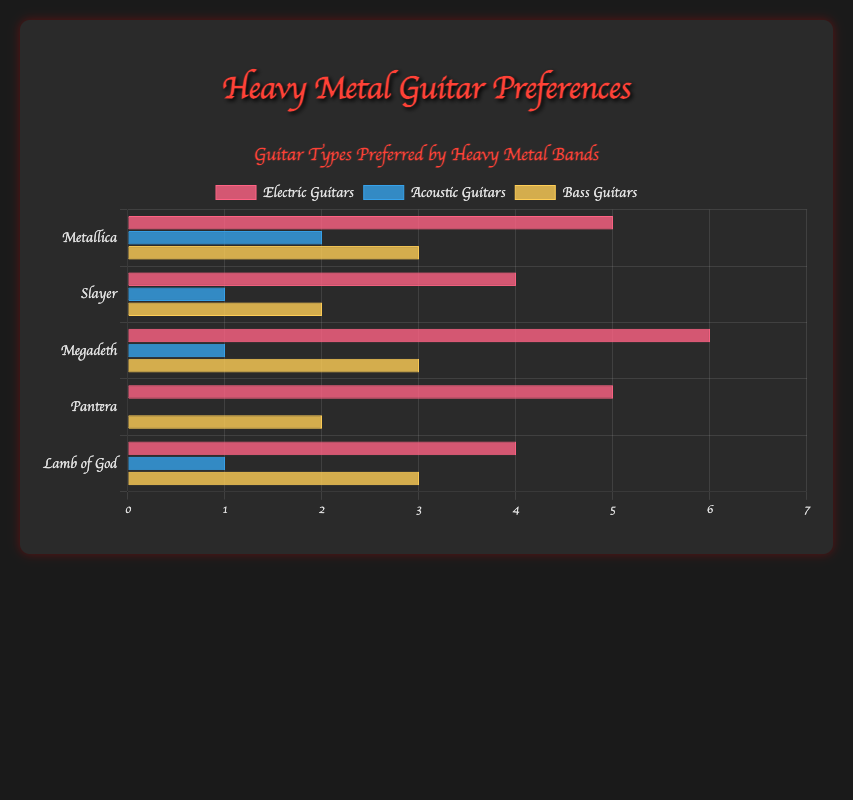Which band prefers the most Electric Guitars? By glancing at the chart, the height of the bars indicated for Electric Guitars can be checked. Megadeth has the tallest bar in this category, representing a count of 6.
Answer: Megadeth Which band has the highest preference for Acoustic Guitars? Checking the heights of the bars representing Acoustic Guitars, Metallica has the tallest bar with a count of 2.
Answer: Metallica What is the total number of Electric Guitars preferred by all bands combined? Summing up the values for Electric Guitars from all bands: Metallica (5), Slayer (4), Megadeth (6), Pantera (5), and Lamb of God (4). Thus, 5 + 4 + 6 + 5 + 4 = 24.
Answer: 24 How many guitars (Electric and Acoustic) does Slayer prefer in total? Slayer prefers 4 Electric Guitars and 1 Acoustic Guitar. Adding these values gives 4 + 1 = 5.
Answer: 5 Which band has the least preference for Bass Guitars? By comparing the heights of the bars for Bass Guitars, Slayer and Pantera both have the lowest count with bars representing 2 Bass Guitars each.
Answer: Slayer and Pantera What is the average number of Acoustic Guitars preferred by the bands? The values for Acoustic Guitars are: Metallica (2), Slayer (1), Megadeth (1), Pantera (0), and Lamb of God (1). Summing these gives 2 + 1 + 1 + 0 + 1 = 5. Dividing by the number of bands (5) gives an average of 5/5 = 1.
Answer: 1 Which type of guitar is preferred the most by Pantera? Within Pantera's data, checking the values: Electric Guitars (5), Acoustic Guitars (0), and Bass Guitars (2). The highest value is for Electric Guitars (5).
Answer: Electric Guitars Among the listed types, which guitar has the lowest preference overall? Summing values for Acoustic Guitars across all bands: 2 (Metallica) + 1 (Slayer) + 1 (Megadeth) + 0 (Pantera) + 1 (Lamb of God) = 5, which is the lowest total among the types.
Answer: Acoustic Guitars How does the number of Electric Guitars preferred by Slayer compare to those preferred by Megadeth? Slayer prefers 4 Electric Guitars while Megadeth prefers 6. Thus, Megadeth prefers 2 more Electric Guitars than Slayer.
Answer: Megadeth prefers 2 more What is the difference in the number of Bass Guitars preferred by Metallica and Pantera combined compared to Lamb of God? Metallica prefers 3 Bass Guitars and Pantera 2, for a total of 3 + 2 = 5. Lamb of God prefers 3 Bass Guitars. The difference is 5 - 3 = 2.
Answer: 2 